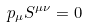<formula> <loc_0><loc_0><loc_500><loc_500>p _ { \mu } S ^ { { \mu } { \nu } } = 0</formula> 